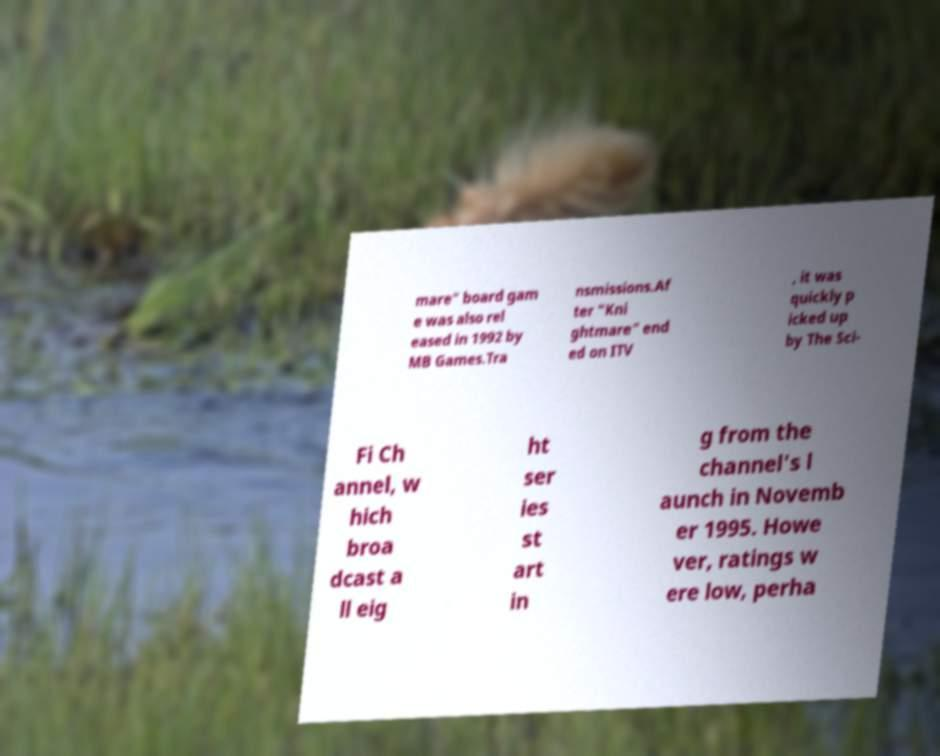I need the written content from this picture converted into text. Can you do that? mare" board gam e was also rel eased in 1992 by MB Games.Tra nsmissions.Af ter "Kni ghtmare" end ed on ITV , it was quickly p icked up by The Sci- Fi Ch annel, w hich broa dcast a ll eig ht ser ies st art in g from the channel's l aunch in Novemb er 1995. Howe ver, ratings w ere low, perha 